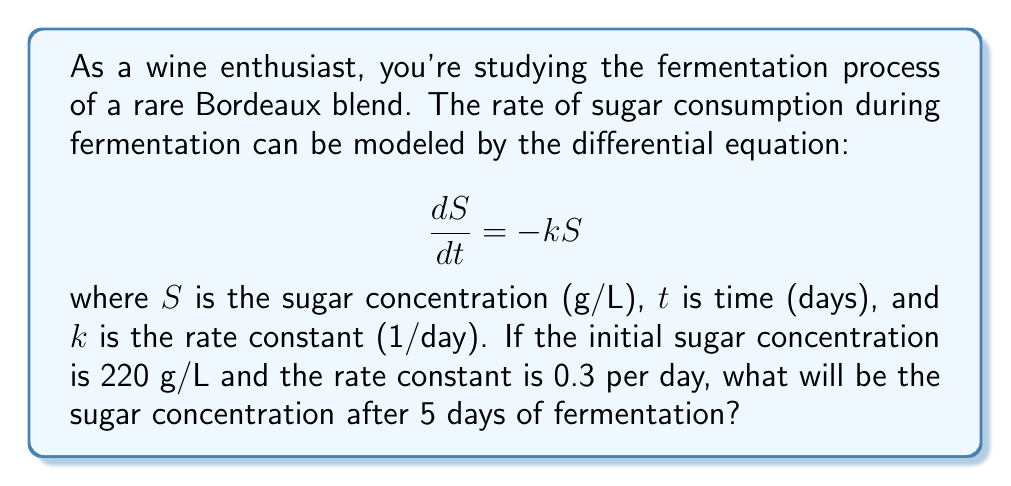Can you answer this question? To solve this problem, we need to use the solution to the first-order linear differential equation:

1) The general solution to $\frac{dS}{dt} = -k S$ is:
   $$S(t) = S_0 e^{-kt}$$
   where $S_0$ is the initial sugar concentration.

2) We're given:
   - $S_0 = 220$ g/L
   - $k = 0.3$ per day
   - $t = 5$ days

3) Substituting these values into the solution:
   $$S(5) = 220 e^{-0.3 \cdot 5}$$

4) Simplify the exponent:
   $$S(5) = 220 e^{-1.5}$$

5) Calculate the result:
   $$S(5) = 220 \cdot 0.2231 \approx 49.08$$

Therefore, after 5 days of fermentation, the sugar concentration will be approximately 49.08 g/L.
Answer: 49.08 g/L 